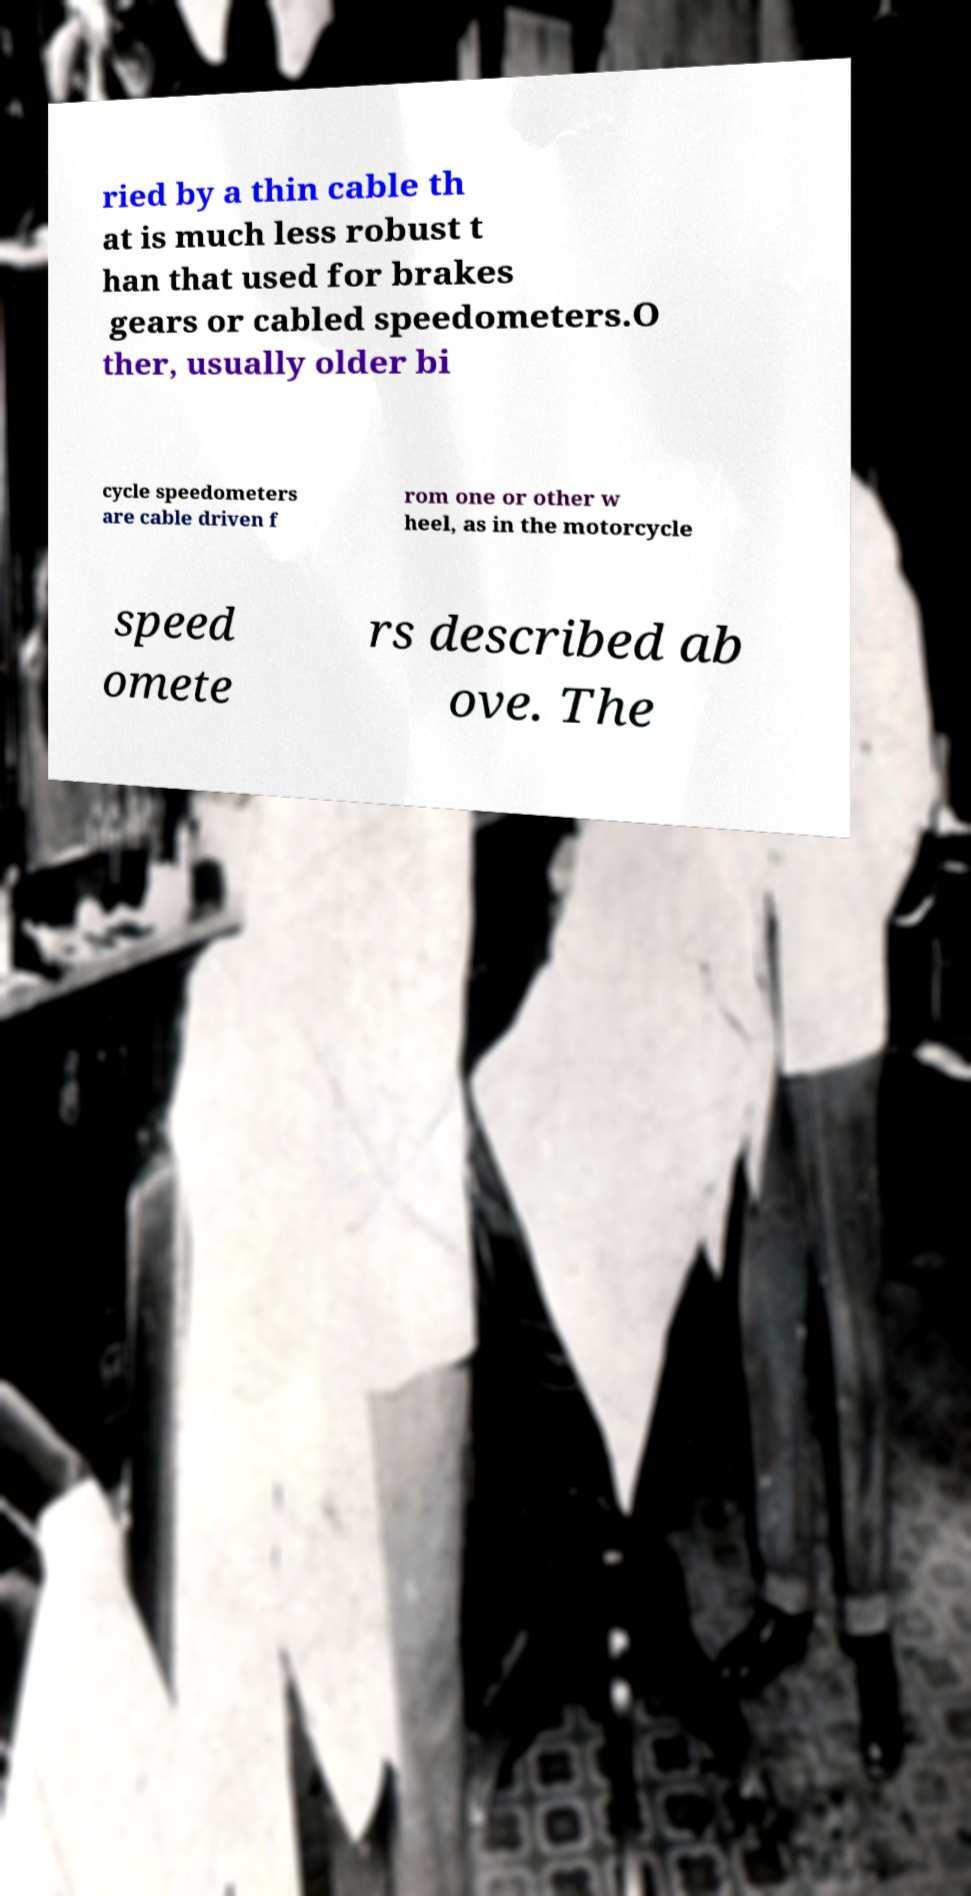For documentation purposes, I need the text within this image transcribed. Could you provide that? ried by a thin cable th at is much less robust t han that used for brakes gears or cabled speedometers.O ther, usually older bi cycle speedometers are cable driven f rom one or other w heel, as in the motorcycle speed omete rs described ab ove. The 